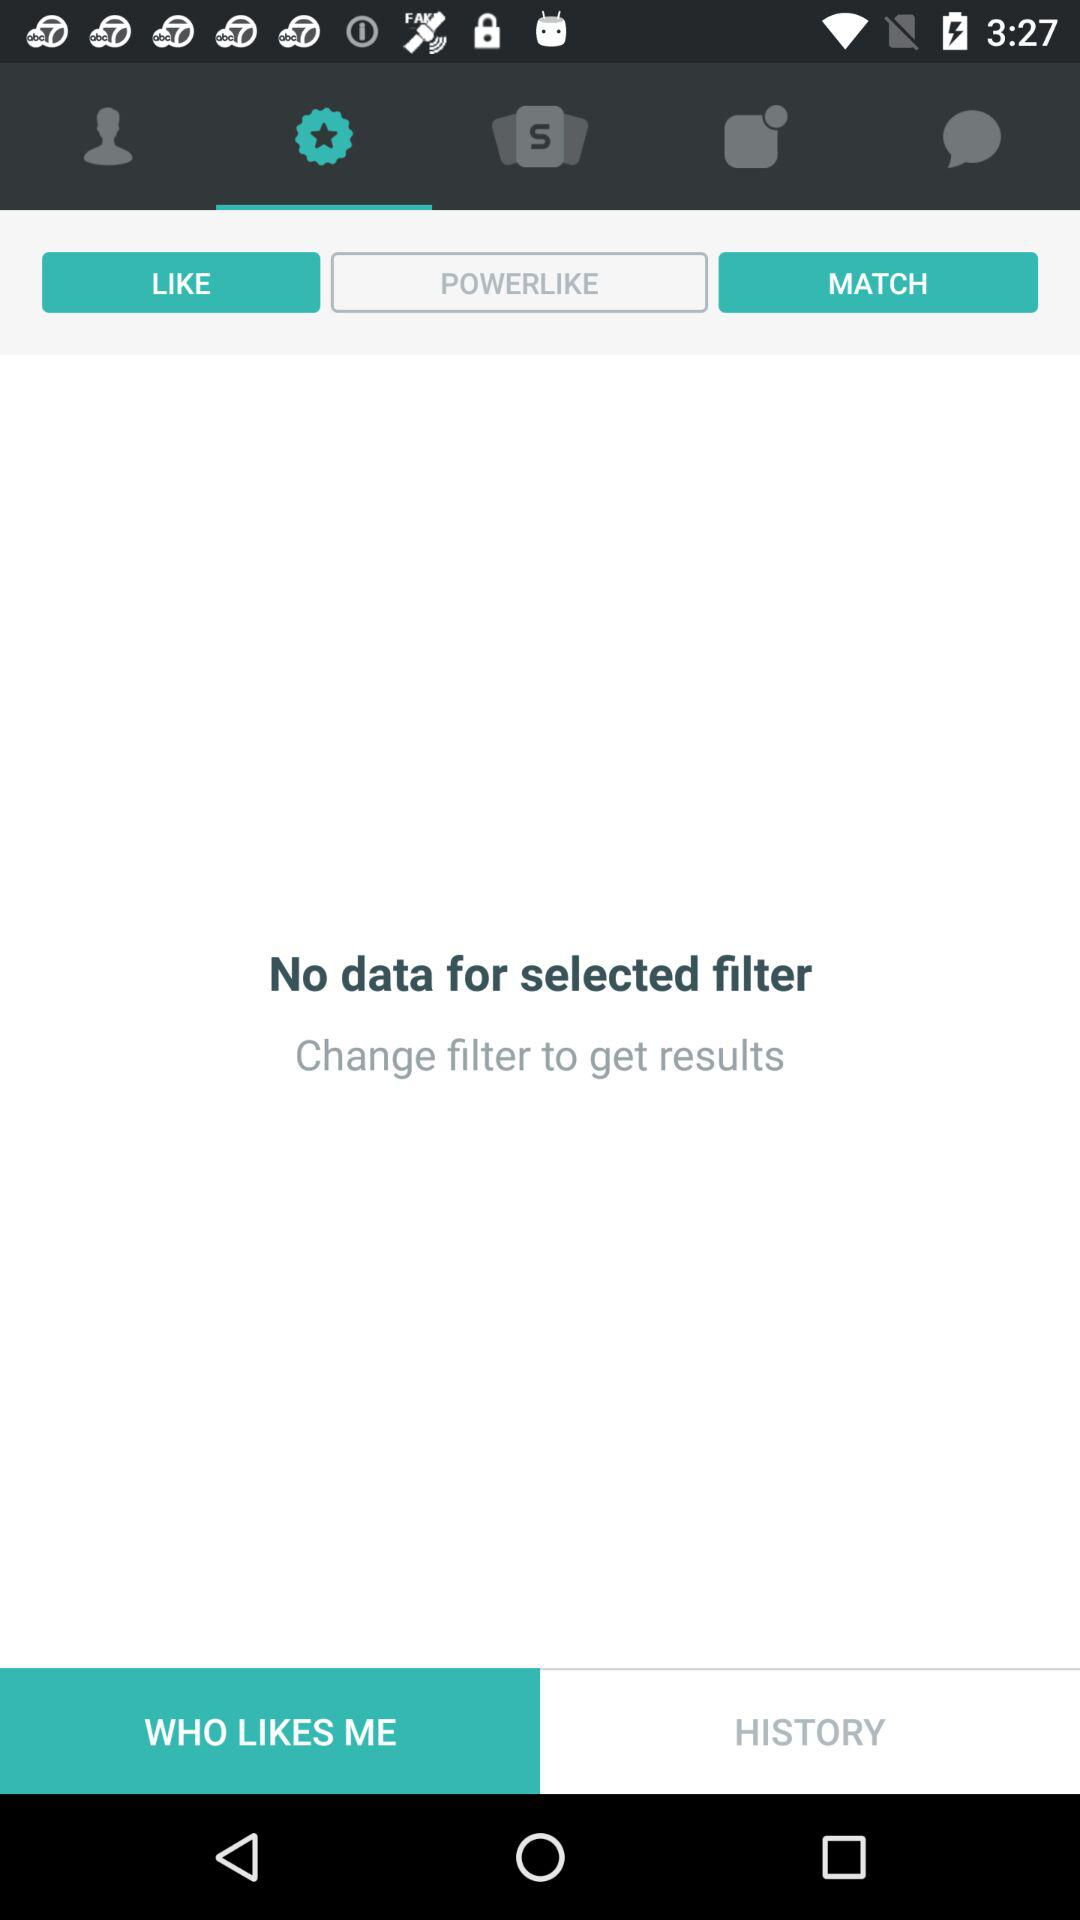Which filters were used in "HISTORY"?
When the provided information is insufficient, respond with <no answer>. <no answer> 